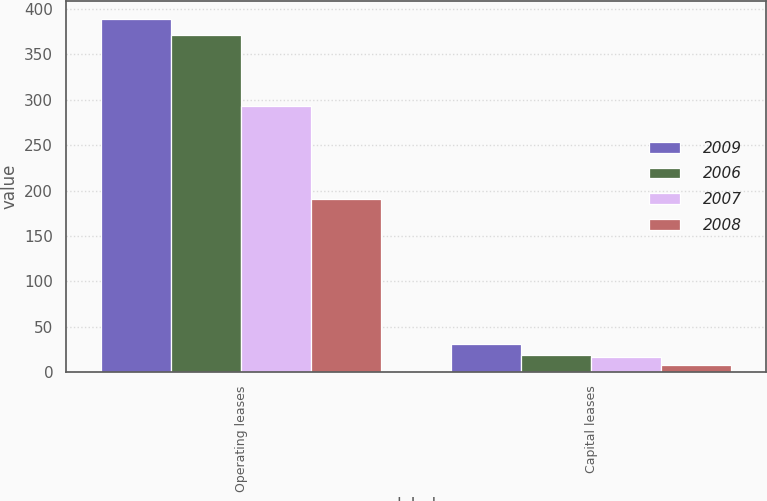<chart> <loc_0><loc_0><loc_500><loc_500><stacked_bar_chart><ecel><fcel>Operating leases<fcel>Capital leases<nl><fcel>2009<fcel>389<fcel>31<nl><fcel>2006<fcel>371<fcel>19<nl><fcel>2007<fcel>293<fcel>17<nl><fcel>2008<fcel>191<fcel>8<nl></chart> 